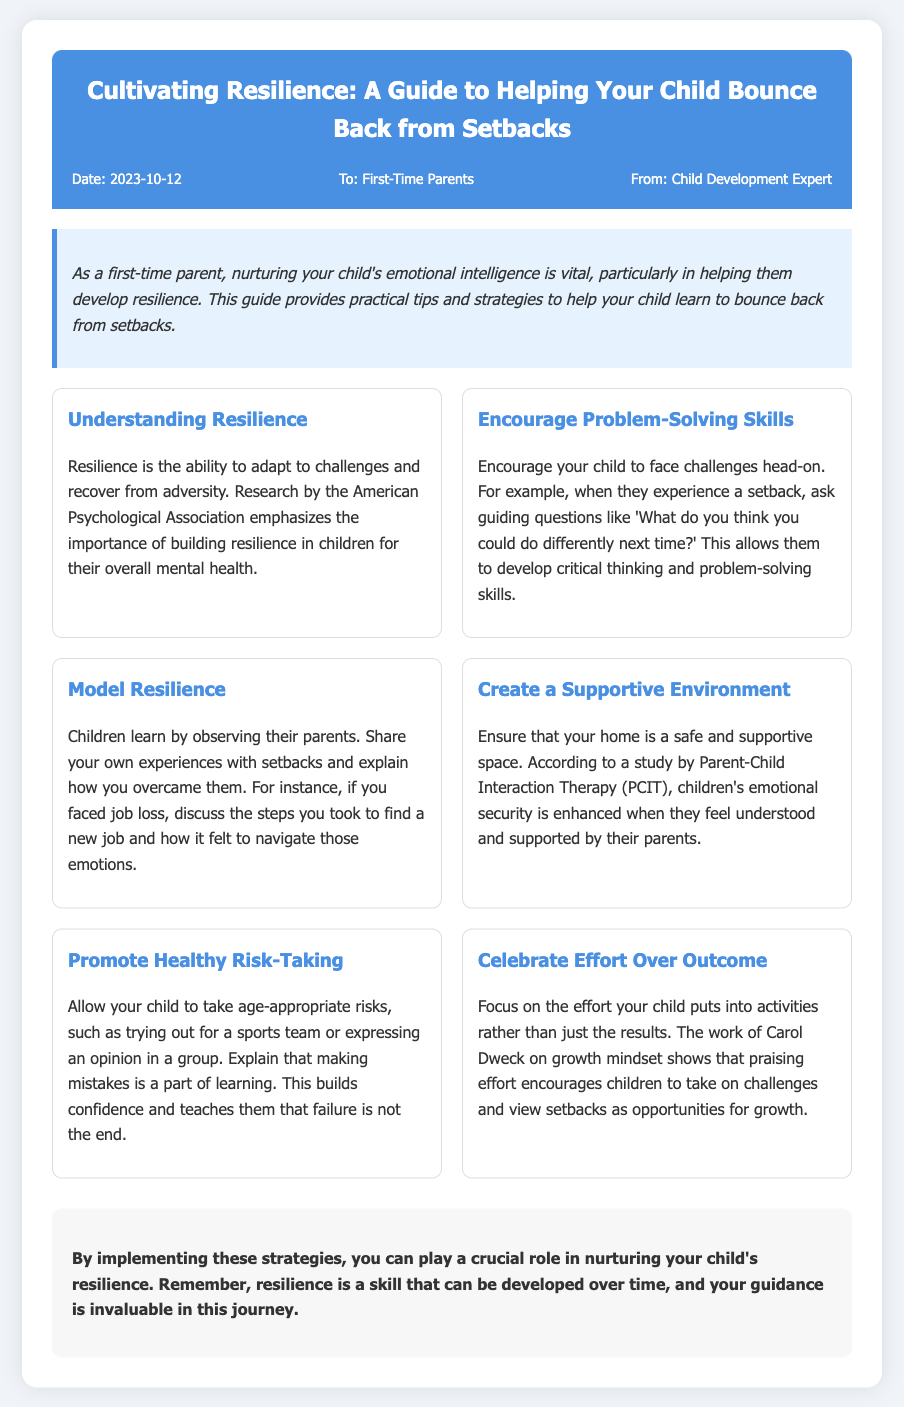what is the title of the memo? The title of the memo is specified at the top of the document.
Answer: Cultivating Resilience: A Guide to Helping Your Child Bounce Back from Setbacks who is the memo addressed to? The memo specifies the intended audience in the header section.
Answer: First-Time Parents what date was the memo issued? The date is provided in the memo's header section.
Answer: 2023-10-12 what is one way to promote resilience according to the memo? The memo includes specific strategies for promoting resilience among children.
Answer: Encourage Problem-Solving Skills who conducted research highlighting the importance of resilience? The memo references a specific organization related to resilience research.
Answer: American Psychological Association what concept does Carol Dweck's work relate to? The memo mentions a concept associated with Carol Dweck's research regarding mindset.
Answer: Growth Mindset what is suggested to focus on when praising a child's efforts? The memo provides insights on how to effectively praise children's efforts.
Answer: Effort Over Outcome what should parents do to model resilience? The memo outlines a specific behavior parents should exhibit.
Answer: Share experiences with setbacks what is essential for fostering emotional security in children? The memo states a key factor that enhances children's emotional security.
Answer: Supportive Environment 